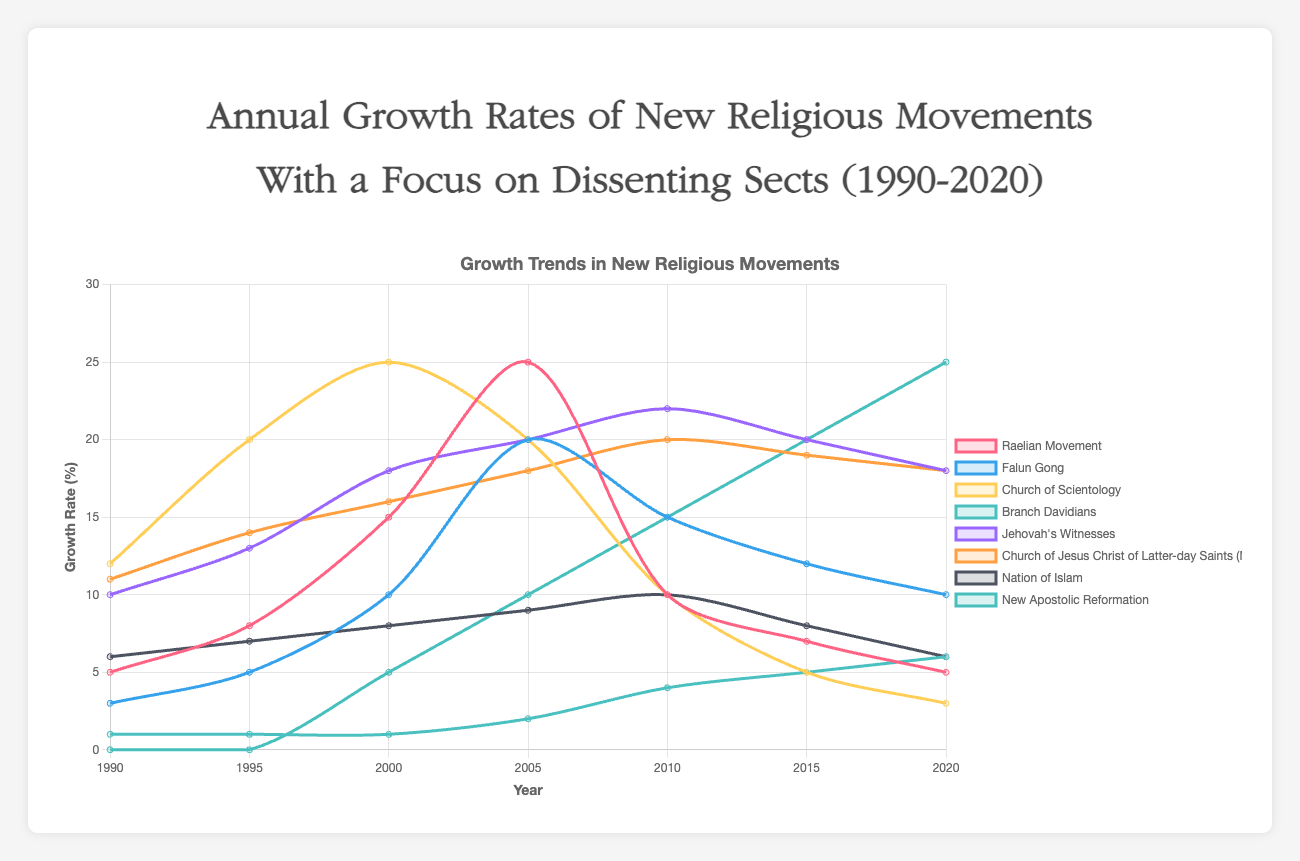What was the growth rate of the Raelian Movement in 2000? The data for the Raelian Movement shows its growth rate was 15 in the year 2000.
Answer: 15 Between the years 2000 and 2010, which movement increased its growth rate the most? First, find the difference in growth rates for each movement between 2000 and 2010. The New Apostolic Reformation went from 5 to 15 (10% increase). The Branch Davidians went from 1 to 4 (3% increase). By comparison, the Raelian Movement decreased, and others saw varying changes. The New Apostolic Reformation had the largest increase of 10.
Answer: New Apostolic Reformation Which movement had the lowest growth rate in 1995? By inspecting the graph or data list for 1995, the Branch Davidians had the lowest growth rate at 1.
Answer: Branch Davidians Compare the growth rates of Jehovah's Witnesses and the Church of Jesus Christ of Latter-day Saints (Mormons) in 2010. Which one was higher? For 2010, the growth rate of Jehovah's Witnesses was 22, while the Church of Jesus Christ of Latter-day Saints (Mormons) had a growth rate of 20. Therefore, Jehovah's Witnesses had a higher growth rate.
Answer: Jehovah's Witnesses Which religious movement shows a continuous increase in growth rate from 1990 to 2020? By checking the data points for each movement, the Branch Davidians and New Apostolic Reformation show continuous increases in their growth rates over the entire period.
Answer: Branch Davidians, New Apostolic Reformation Which year did the Raelian Movement experience its peak growth rate? Looking at the Raelian Movement's data, the peak growth rate occurred in 2005 with a value of 25.
Answer: 2005 What is the average growth rate of Falun Gong over the years 1990-2020? Add all the growth rates and divide by the number of data points: (3 + 5 + 10 + 20 + 15 + 12 + 10) / 7 = 75 / 7 ≈ 10.7
Answer: 10.7 Which movement showed the steepest decline in growth rate after reaching its peak? The Church of Scientology peaked at 25 in 2000 and declined to 3 by 2020. This shows the steepest decline in growth rate among the movements.
Answer: Church of Scientology 